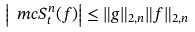Convert formula to latex. <formula><loc_0><loc_0><loc_500><loc_500>\left | \ m c S _ { t } ^ { n } ( f ) \right | \leq \| g \| _ { 2 , n } \| f \| _ { 2 , n }</formula> 